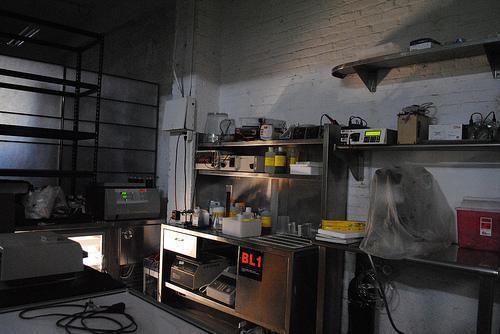How many aardvarks are seen in the picture?
Give a very brief answer. 0. 